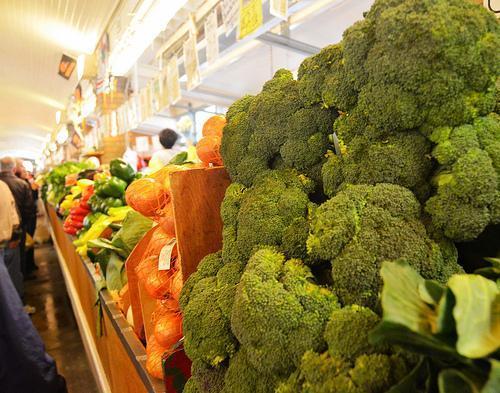How many carrots are in the photo?
Give a very brief answer. 0. 